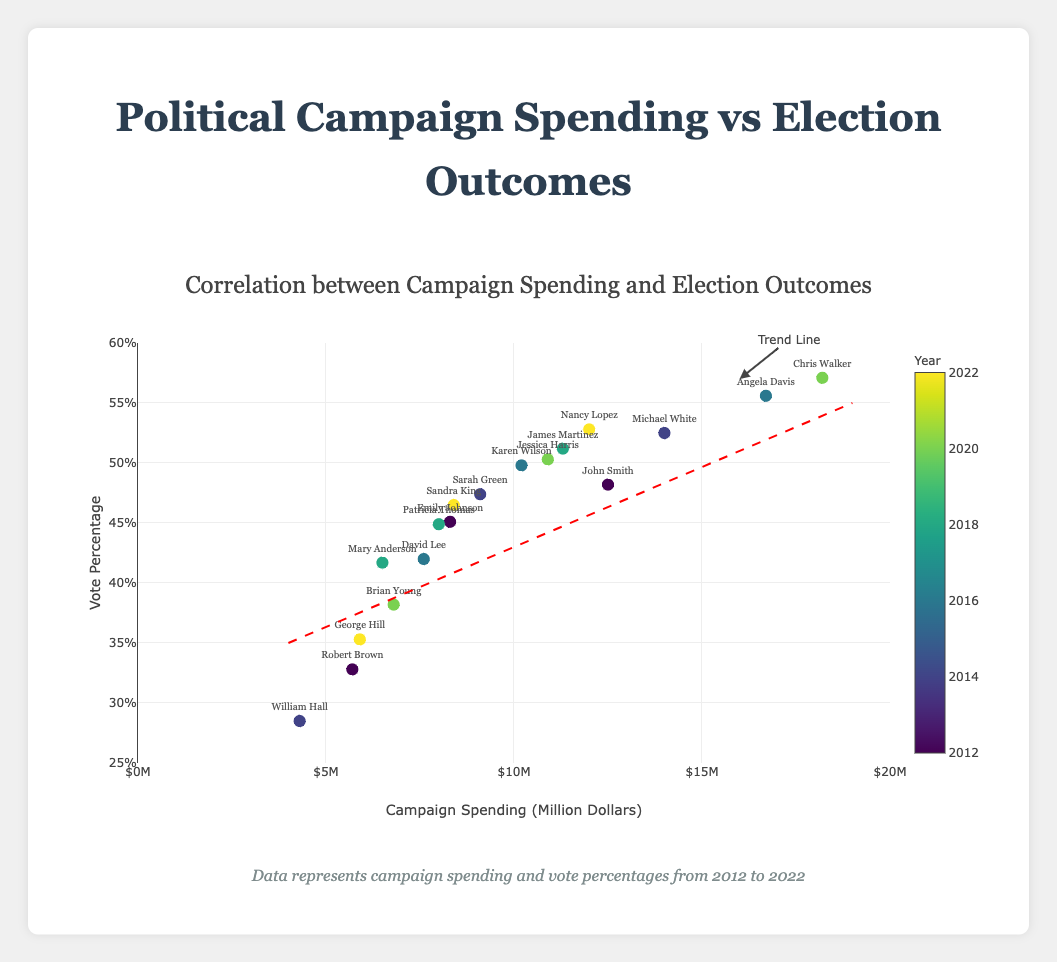What's the title of the scatter plot? The title is located at the top of the figure and reads, "Correlation between Campaign Spending and Election Outcomes".
Answer: Correlation between Campaign Spending and Election Outcomes How many data points are plotted in the figure? Each data point corresponds to a candidate's campaign spending and vote percentage, and there are 18 candidates listed.
Answer: 18 What's the vote percentage corresponding to the highest campaign spending? The x-axis represents the campaign spending and the highest spending is 18.2 million dollars by Chris Walker, which corresponds to a vote percentage of 57.1%.
Answer: 57.1% Who spent 12 million dollars on their campaign and what was their vote percentage? By looking at the labeled data points and the x-axis, Nancy Lopez spent 12 million dollars and her vote percentage was 52.8%.
Answer: Nancy Lopez, 52.8% Which candidate from 2020 had the lowest vote percentage and how much did they spend? The candidates from 2020 have colors indicating the year and we look for the lowest y-value among them. Brian Young had the lowest vote percentage at 38.2% and spent 6.8 million dollars.
Answer: Brian Young, 6.8 million dollars What's the trend line indicating about the relationship between campaign spending and election outcomes? The trend line is dashed and sloped upwards from left to right, indicating a positive correlation: as campaign spending increases, the vote percentage tends to increase.
Answer: Positive correlation What is the median campaign spending among all candidates? To find the median, list all 18 spending values in ascending order: 4.3, 5.7, 5.9, 6.5, 6.8, 7.6, 8.0, 8.3, 8.4, 9.1, 10.2, 10.9, 11.3, 12.0, 12.5, 14.0, 16.7, 18.2. The median is the average of the 9th and 10th values: (8.4 + 9.1)/2 = 8.75.
Answer: 8.75 million dollars How many candidates spent more than 10 million dollars on their campaign? Counting the data points with campaign spending greater than 10 million dollars gives us John Smith, Michael White, Angela Davis, Karen Wilson, James Martinez, Chris Walker, Jessica Harris, Nancy Lopez. That makes 8 candidates.
Answer: 8 What's the vote percentage difference between the candidate with the highest and the lowest spending? The highest spending was by Chris Walker at 18.2 million dollars (57.1%) and the lowest was by William Hall at 4.3 million dollars (28.5%). The difference is 57.1% - 28.5% = 28.6%.
Answer: 28.6% Which candidate had the closest vote percentage to their spending amount if we treat spending as a percentage? Comparing the spending and vote percentages, the closest match numerically is Nancy Lopez, with 12 million dollars spending and 52.8% vote percentage. The absolute difference is smallest with almost 40.8%.
Answer: Nancy Lopez 